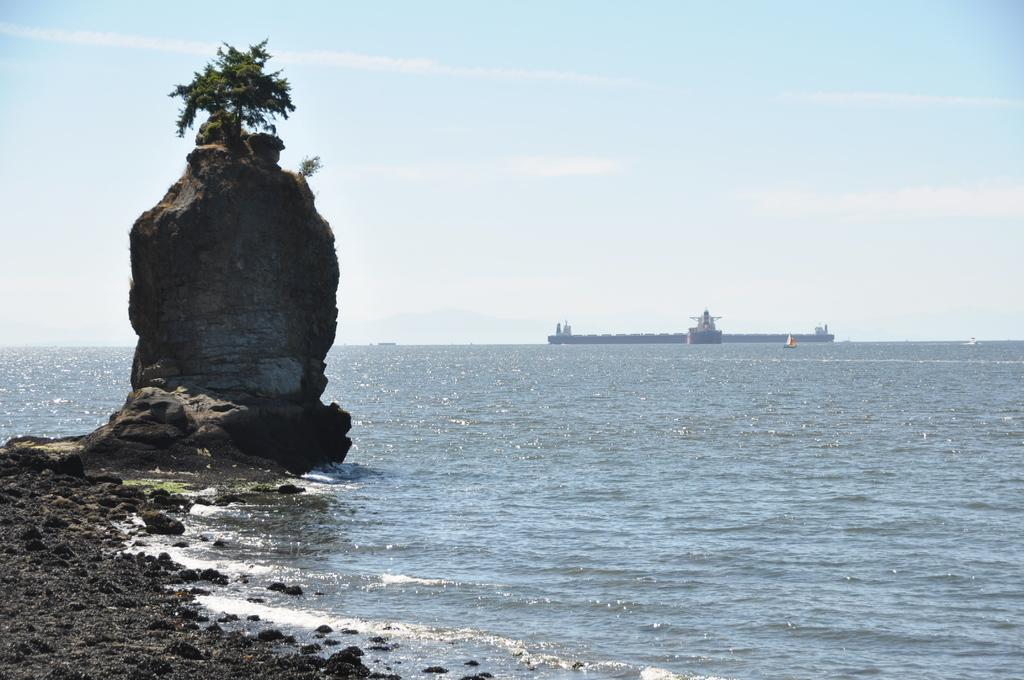What type of vehicles are present in the image? There are boats and a ship in the image. Where are the boats and ship located? They are on the water in the image. What other objects can be seen in the image? There are rocks, a tree on top of a rock, and the sky visible in the background. What is the condition of the sky in the image? The sky is visible in the background of the image, and there are clouds present. What type of story is being told by the boats and ship in the image? There is no story being told by the boats and ship in the image; they are simply objects in the scene. Is there any quicksand present in the image? There is no quicksand present in the image; it features boats, a ship, rocks, a tree, and the sky. 